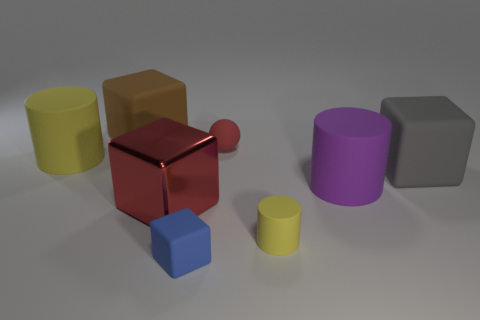What is the lighting condition in the scene, and how does it affect the appearance of the objects? The scene is illuminated by what appears to be a diffused overhead light source, creating soft shadows under and around the objects. This lighting condition enhances the perception of depth and texture on the objects' surfaces. It provides enough brightness to highlight the reflective qualities of the shiny materials, like the red cube, while also revealing the matte appearance of the other objects, which absorb rather than reflect the light. 